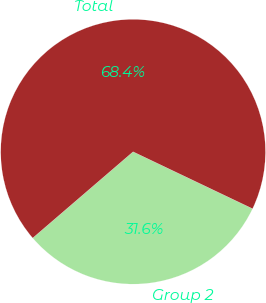Convert chart to OTSL. <chart><loc_0><loc_0><loc_500><loc_500><pie_chart><fcel>Group 2<fcel>Total<nl><fcel>31.62%<fcel>68.38%<nl></chart> 